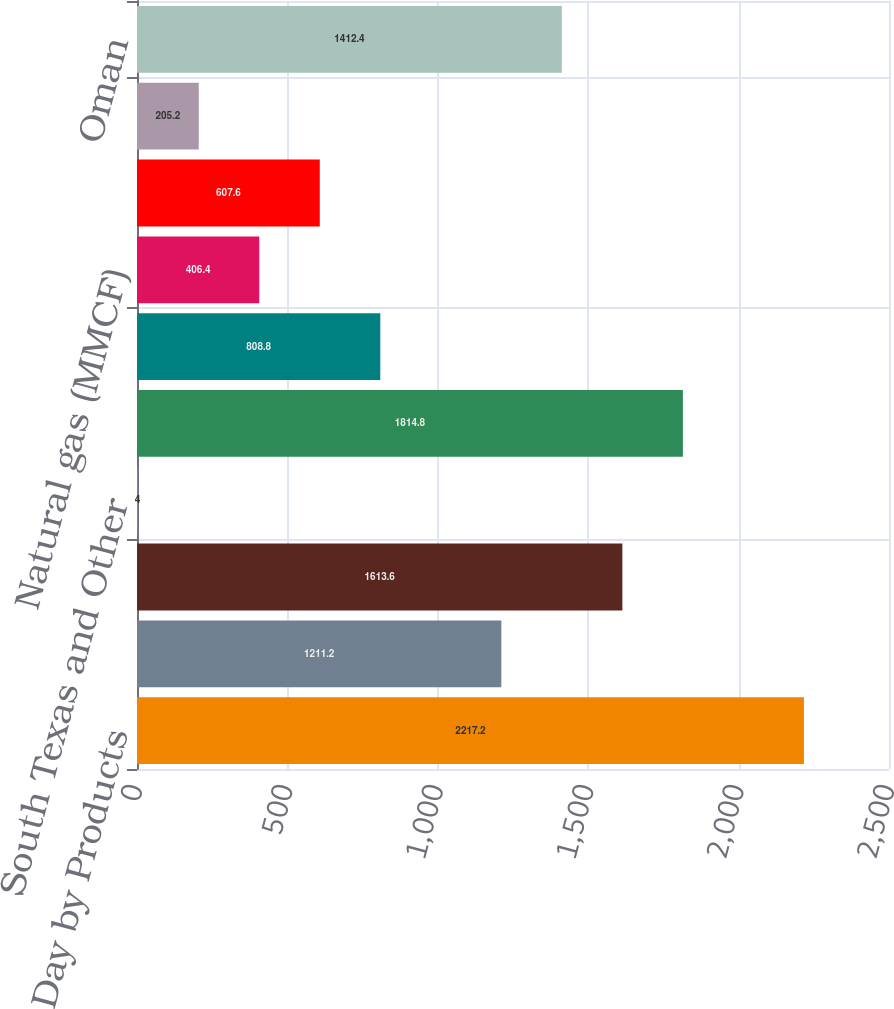<chart> <loc_0><loc_0><loc_500><loc_500><bar_chart><fcel>Production per Day by Products<fcel>Permian Resources<fcel>Permian EOR<fcel>South Texas and Other<fcel>Total<fcel>Oil (MBBL)<fcel>Natural gas (MMCF)<fcel>Al Hosn Gas<fcel>Dolphin<fcel>Oman<nl><fcel>2217.2<fcel>1211.2<fcel>1613.6<fcel>4<fcel>1814.8<fcel>808.8<fcel>406.4<fcel>607.6<fcel>205.2<fcel>1412.4<nl></chart> 